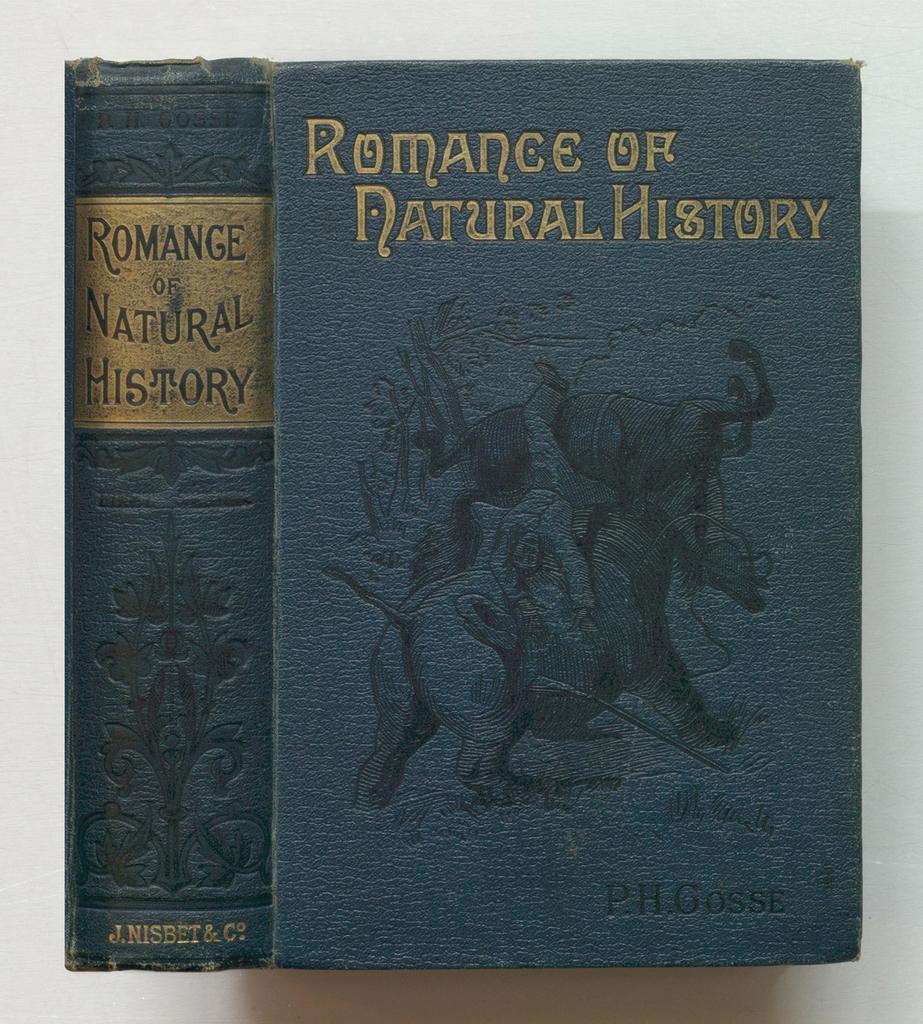Could you give a brief overview of what you see in this image? In this picture i can see the books on the table. On the cover page i can see some animals. In the bottom right corner of the book there is a author´s name. At the top of the book there is a content name. 